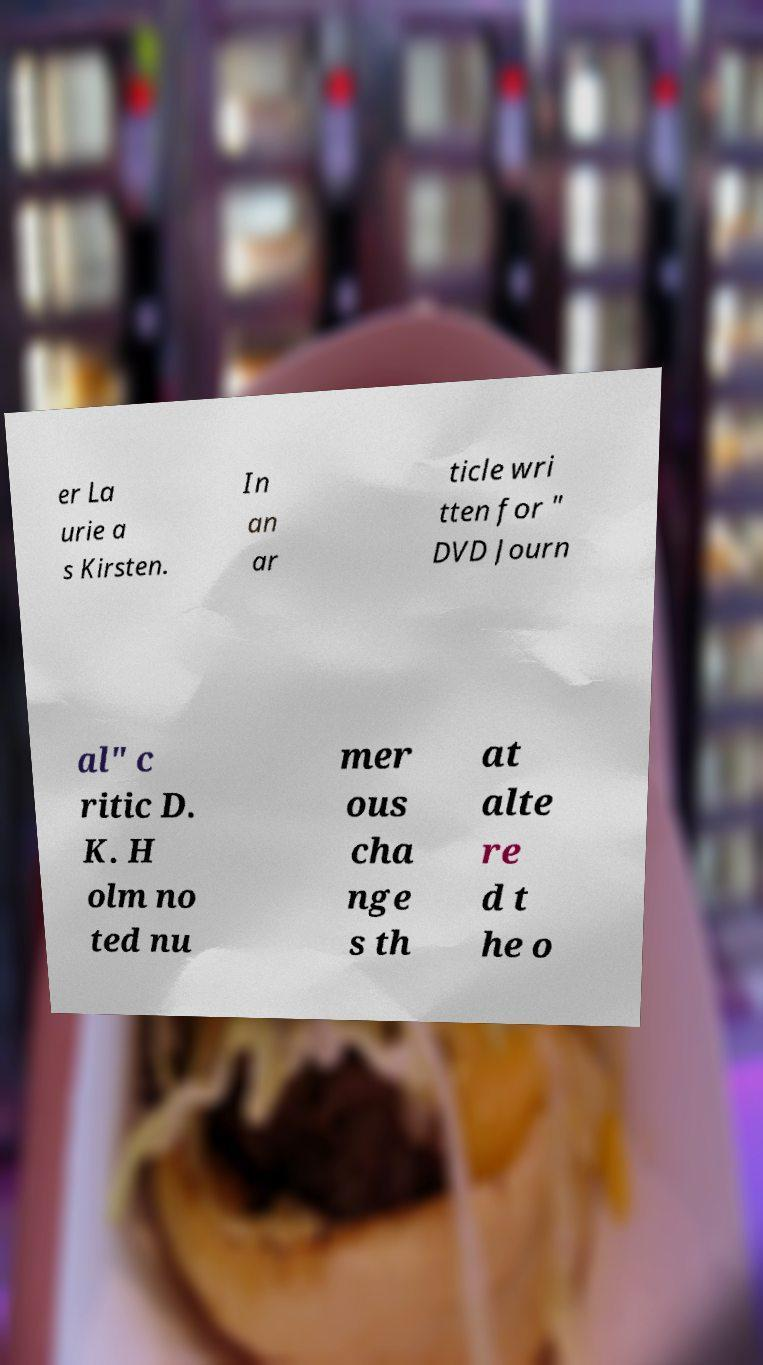Could you assist in decoding the text presented in this image and type it out clearly? er La urie a s Kirsten. In an ar ticle wri tten for " DVD Journ al" c ritic D. K. H olm no ted nu mer ous cha nge s th at alte re d t he o 